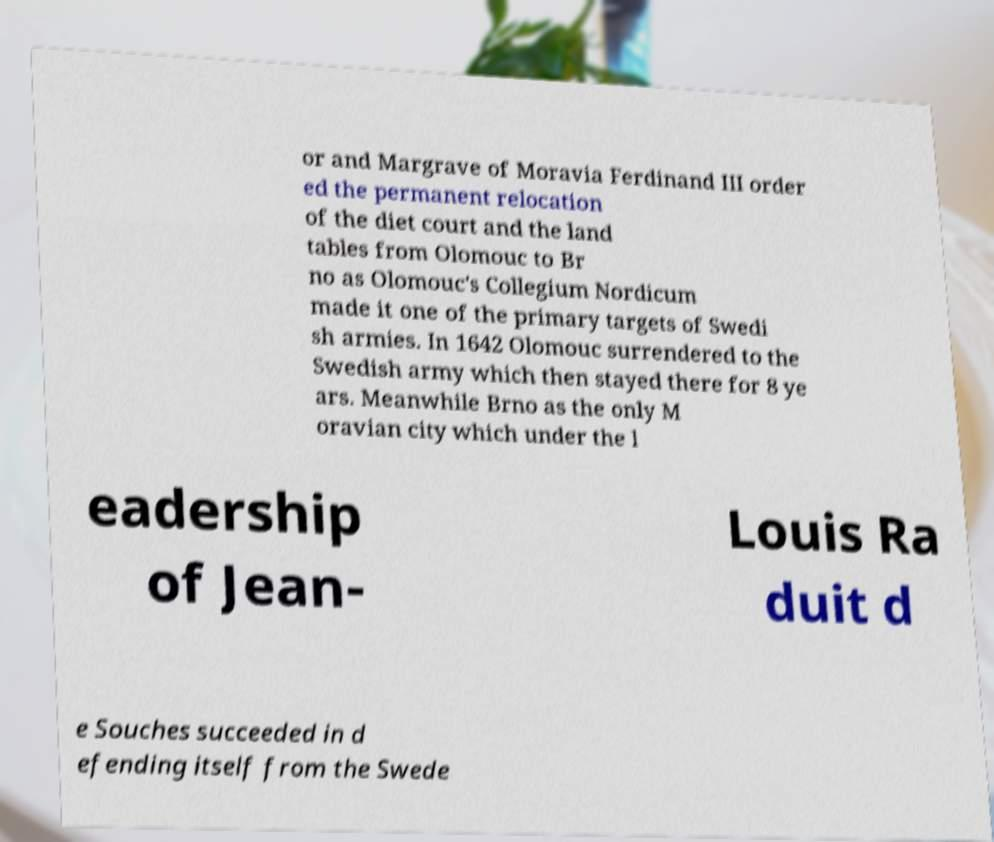Can you read and provide the text displayed in the image?This photo seems to have some interesting text. Can you extract and type it out for me? or and Margrave of Moravia Ferdinand III order ed the permanent relocation of the diet court and the land tables from Olomouc to Br no as Olomouc's Collegium Nordicum made it one of the primary targets of Swedi sh armies. In 1642 Olomouc surrendered to the Swedish army which then stayed there for 8 ye ars. Meanwhile Brno as the only M oravian city which under the l eadership of Jean- Louis Ra duit d e Souches succeeded in d efending itself from the Swede 